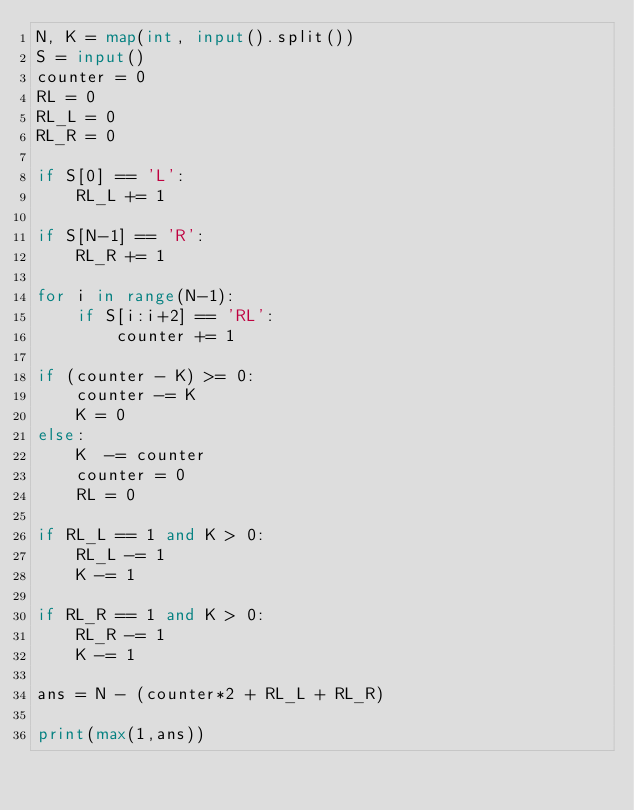Convert code to text. <code><loc_0><loc_0><loc_500><loc_500><_Python_>N, K = map(int, input().split())
S = input()
counter = 0
RL = 0
RL_L = 0
RL_R = 0

if S[0] == 'L':
    RL_L += 1

if S[N-1] == 'R':
    RL_R += 1

for i in range(N-1):
    if S[i:i+2] == 'RL':
        counter += 1

if (counter - K) >= 0:
    counter -= K
    K = 0
else:
    K  -= counter
    counter = 0
    RL = 0

if RL_L == 1 and K > 0:
    RL_L -= 1
    K -= 1

if RL_R == 1 and K > 0:
    RL_R -= 1
    K -= 1

ans = N - (counter*2 + RL_L + RL_R)

print(max(1,ans))</code> 